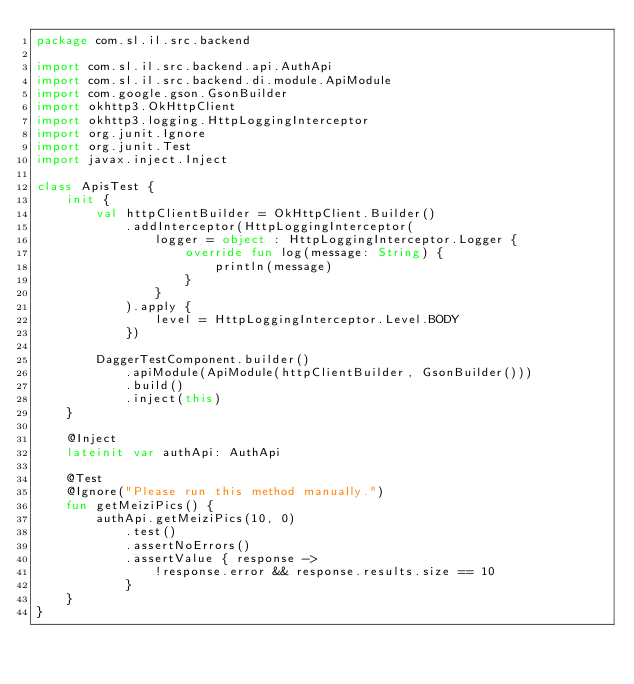Convert code to text. <code><loc_0><loc_0><loc_500><loc_500><_Kotlin_>package com.sl.il.src.backend

import com.sl.il.src.backend.api.AuthApi
import com.sl.il.src.backend.di.module.ApiModule
import com.google.gson.GsonBuilder
import okhttp3.OkHttpClient
import okhttp3.logging.HttpLoggingInterceptor
import org.junit.Ignore
import org.junit.Test
import javax.inject.Inject

class ApisTest {
    init {
        val httpClientBuilder = OkHttpClient.Builder()
            .addInterceptor(HttpLoggingInterceptor(
                logger = object : HttpLoggingInterceptor.Logger {
                    override fun log(message: String) {
                        println(message)
                    }
                }
            ).apply {
                level = HttpLoggingInterceptor.Level.BODY
            })

        DaggerTestComponent.builder()
            .apiModule(ApiModule(httpClientBuilder, GsonBuilder()))
            .build()
            .inject(this)
    }

    @Inject
    lateinit var authApi: AuthApi

    @Test
    @Ignore("Please run this method manually.")
    fun getMeiziPics() {
        authApi.getMeiziPics(10, 0)
            .test()
            .assertNoErrors()
            .assertValue { response ->
                !response.error && response.results.size == 10
            }
    }
}
</code> 